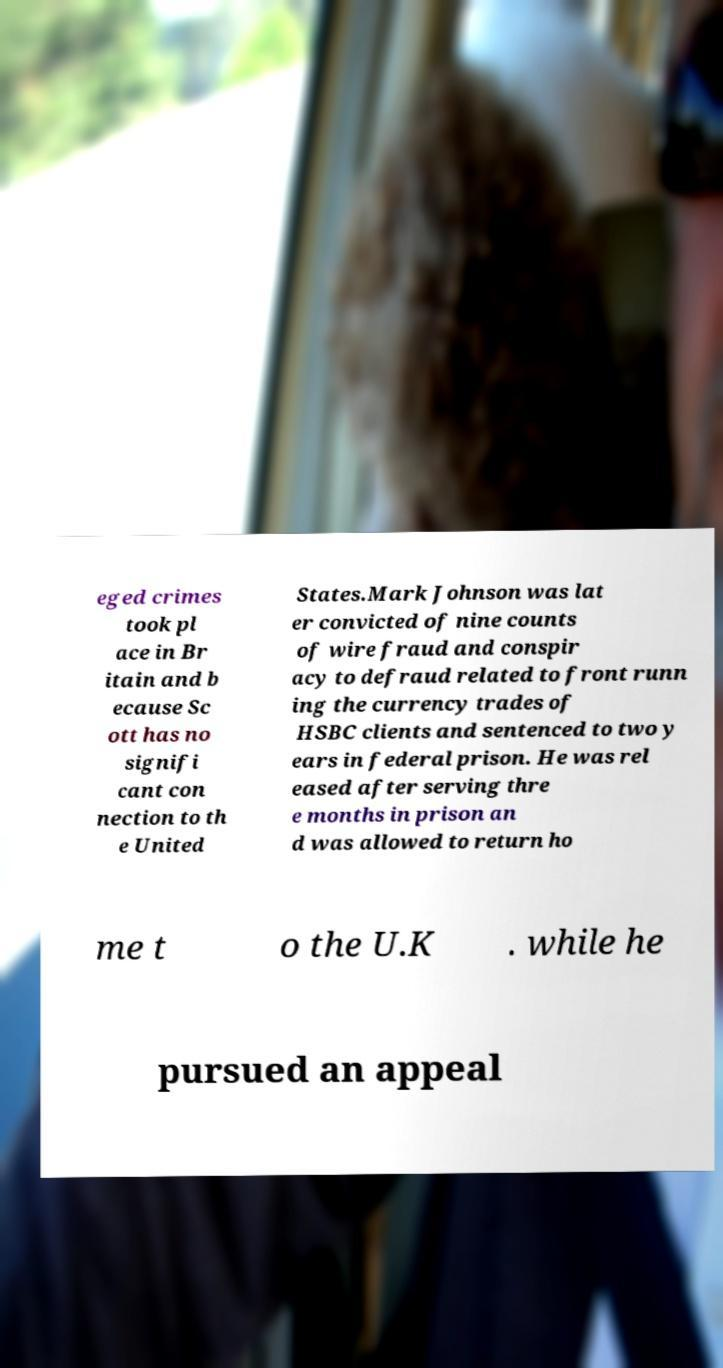Can you read and provide the text displayed in the image?This photo seems to have some interesting text. Can you extract and type it out for me? eged crimes took pl ace in Br itain and b ecause Sc ott has no signifi cant con nection to th e United States.Mark Johnson was lat er convicted of nine counts of wire fraud and conspir acy to defraud related to front runn ing the currency trades of HSBC clients and sentenced to two y ears in federal prison. He was rel eased after serving thre e months in prison an d was allowed to return ho me t o the U.K . while he pursued an appeal 